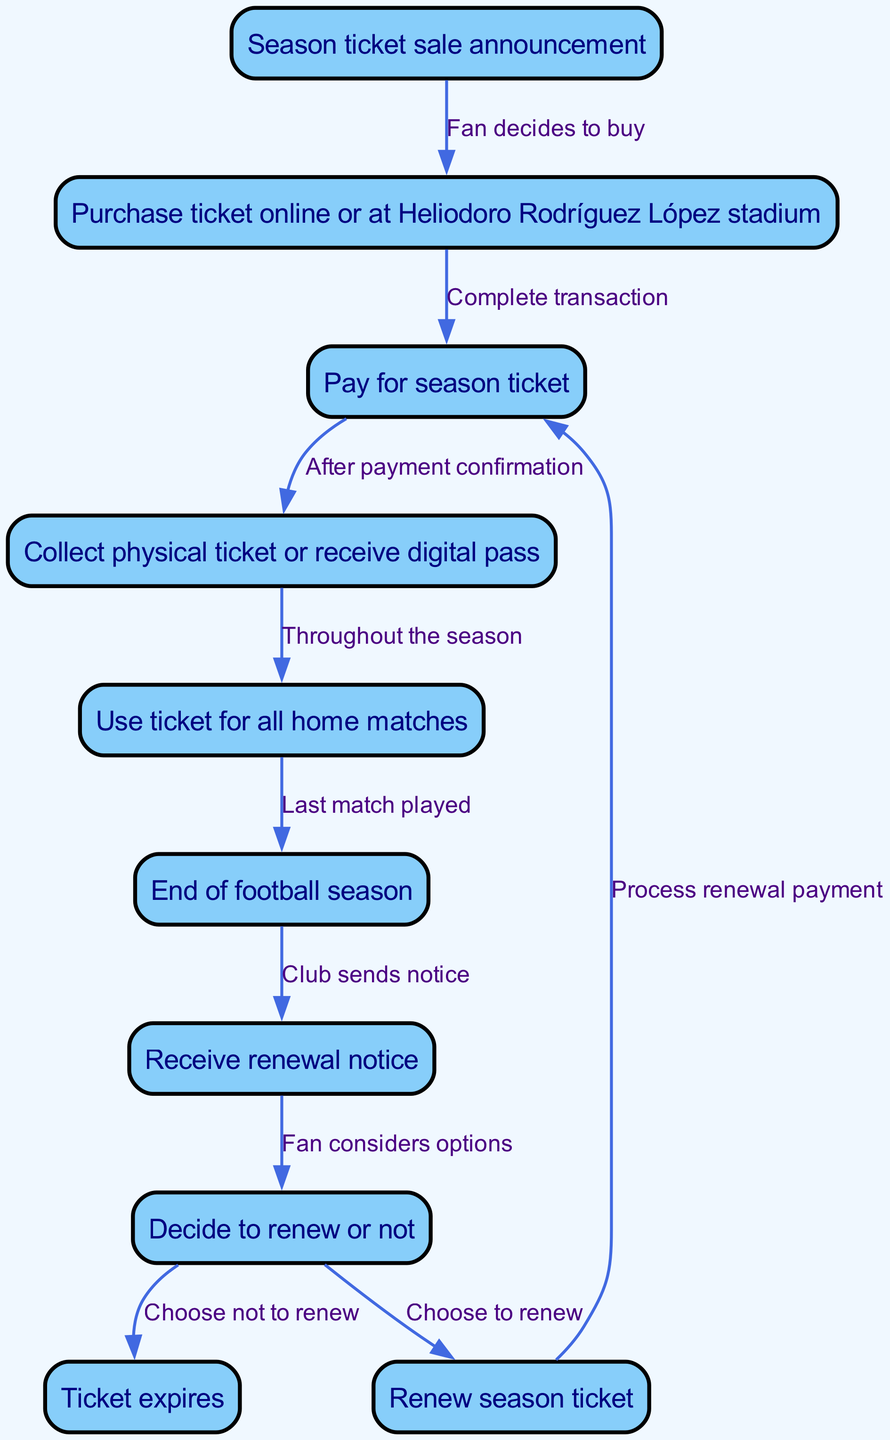What triggers the start of the season ticket lifecycle? The first node labeled "Season ticket sale announcement" indicates that this is the triggering event for the lifecycle.
Answer: Season ticket sale announcement How many nodes are there in the flow chart? By counting all the different stages in the diagram, including the start and end nodes, we find a total of 10 nodes.
Answer: 10 What follows after the purchase of the ticket? After the node labeled "Purchase ticket online or at Heliodoro Rodríguez López stadium," the next node in the flow indicates that the user makes a "Pay for season ticket."
Answer: Pay for season ticket What happens if the fan decides not to renew the season ticket? The diagram shows that if the fan chooses not to renew, it leads to the "Ticket expires" node, indicating the end of the cycle for that season ticket.
Answer: Ticket expires What is the action required after receiving the renewal notice? The next step after receiving the "Receive renewal notice" is a decision-making process, as represented in the node labeled "Decide to renew or not."
Answer: Decide to renew or not Which two nodes have an edge indicating a decision? The nodes "decision" and "renewal_notice" are connected by an edge, as indicated by the flow that showcases the consideration of the renewal process.
Answer: decision and renewal_notice What is the final outcome if a fan chooses to renew the ticket? In the case that a fan decides to renew their season ticket, the next step is to "Process renewal payment," as shown by the flow from the "renew" node returning to "payment."
Answer: Process renewal payment Which node indicates the last match played in the season? The diagram illustrates that "Last match played" corresponds to the edge leading from the "Use ticket for all home matches" to the "End of football season" node.
Answer: End of football season What must be completed before collecting the ticket? According to the flow, the action needed before collecting the ticket is completing the "Pay for season ticket" node, as it follows the payment process.
Answer: Pay for season ticket 